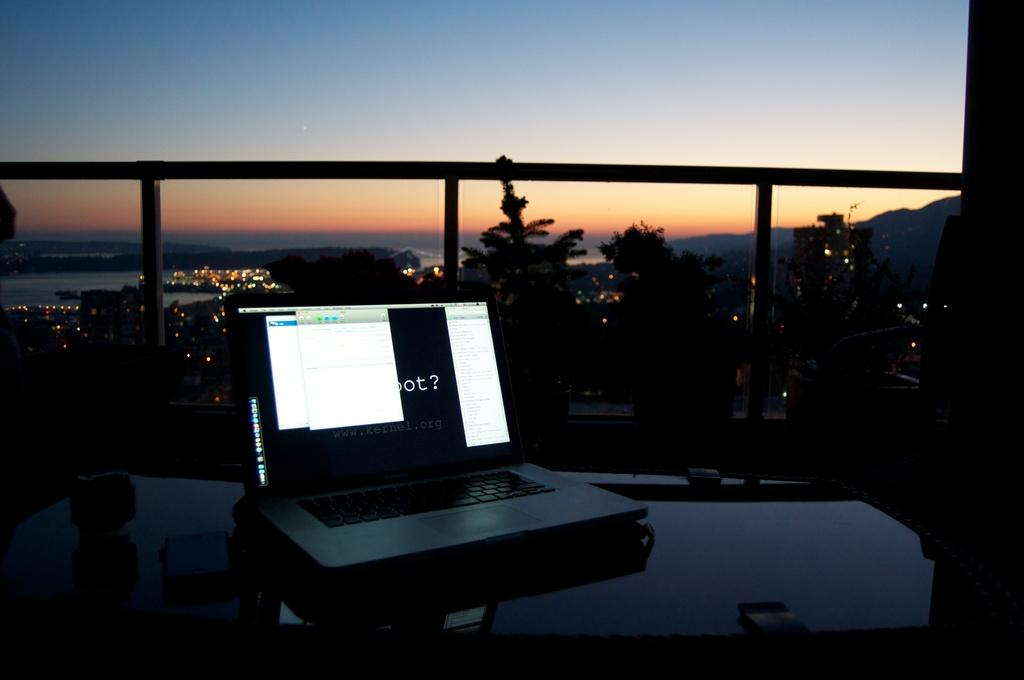<image>
Render a clear and concise summary of the photo. A computer on a black surface with the website kernel listed on it. 